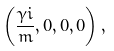<formula> <loc_0><loc_0><loc_500><loc_500>\left ( \frac { \gamma i } { m } , 0 , 0 , 0 \right ) ,</formula> 